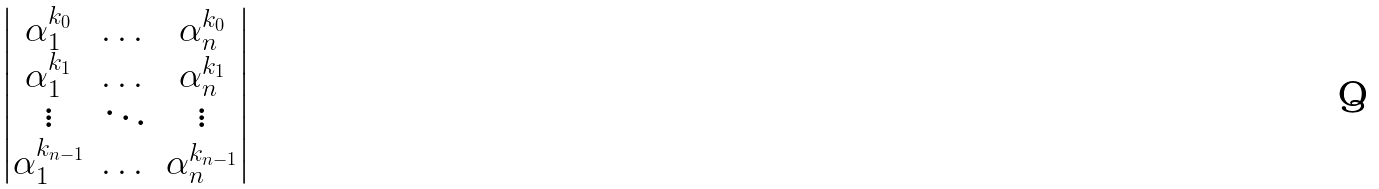Convert formula to latex. <formula><loc_0><loc_0><loc_500><loc_500>\begin{vmatrix} \alpha _ { 1 } ^ { k _ { 0 } } & \dots & \alpha _ { n } ^ { k _ { 0 } } \\ \alpha _ { 1 } ^ { k _ { 1 } } & \dots & \alpha _ { n } ^ { k _ { 1 } } \\ \vdots & \ddots & \vdots \\ \alpha _ { 1 } ^ { k _ { n - 1 } } & \dots & \alpha _ { n } ^ { k _ { n - 1 } } \\ \end{vmatrix}</formula> 